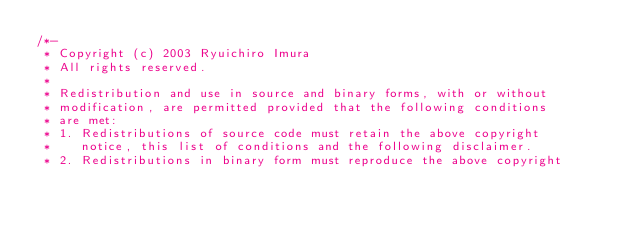Convert code to text. <code><loc_0><loc_0><loc_500><loc_500><_C_>/*-
 * Copyright (c) 2003 Ryuichiro Imura
 * All rights reserved.
 *
 * Redistribution and use in source and binary forms, with or without
 * modification, are permitted provided that the following conditions
 * are met:
 * 1. Redistributions of source code must retain the above copyright
 *    notice, this list of conditions and the following disclaimer.
 * 2. Redistributions in binary form must reproduce the above copyright</code> 